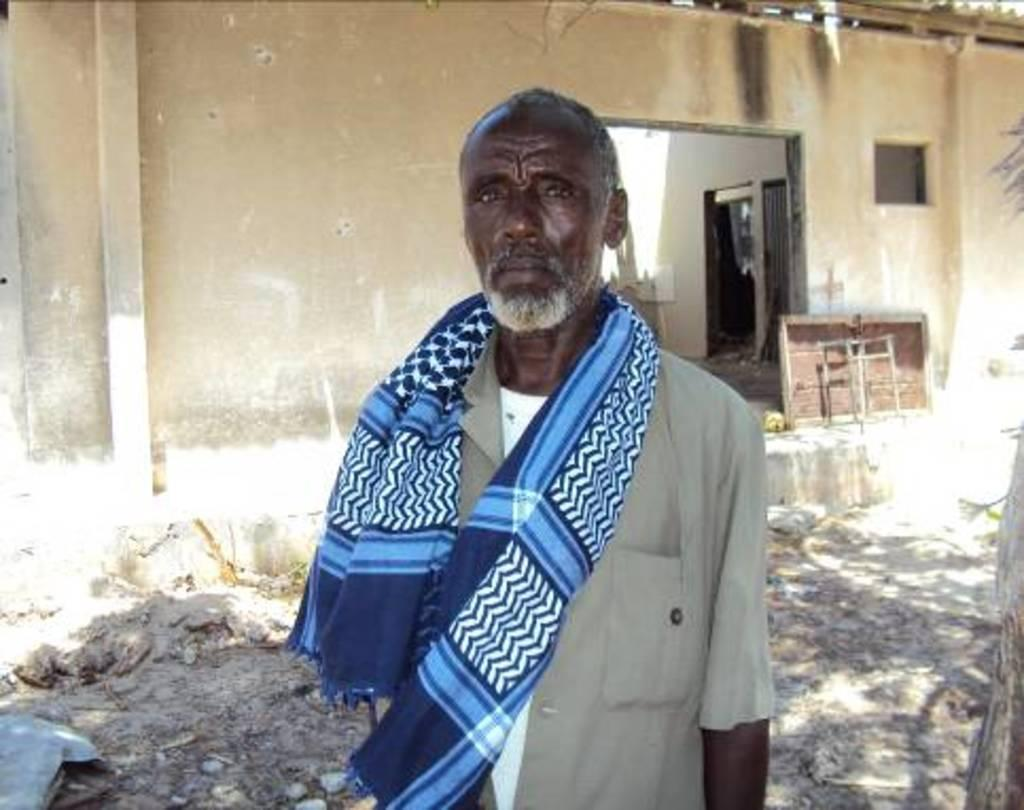What is the man in the image doing? The man is standing in the image. What is the man wearing on his upper body? The man is wearing a shirt. What is the man wearing around his waist? The man is wearing a towel. What can be inferred about the location in the image? The image appears to show a demolished building. Can you identify any architectural features in the image? There might be a window and a wooden door visible in the image. What structural element can be seen in the image? There is a pillar visible in the image. What type of smile can be seen on the man's face in the image? There is no indication of the man's facial expression in the image, so it cannot be determined if he is smiling or not. 